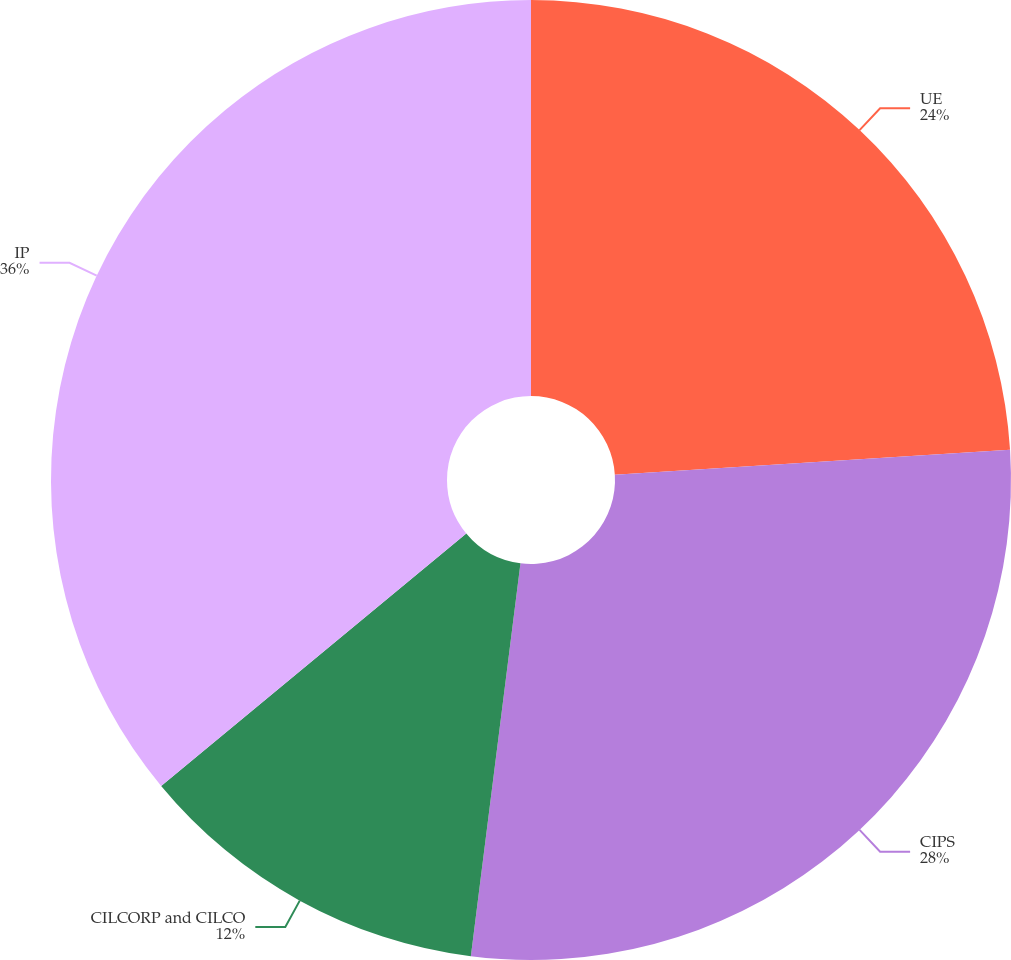Convert chart to OTSL. <chart><loc_0><loc_0><loc_500><loc_500><pie_chart><fcel>UE<fcel>CIPS<fcel>CILCORP and CILCO<fcel>IP<nl><fcel>24.0%<fcel>28.0%<fcel>12.0%<fcel>36.0%<nl></chart> 